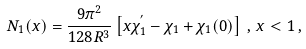<formula> <loc_0><loc_0><loc_500><loc_500>N _ { 1 } ( x ) = \frac { 9 \pi ^ { 2 } } { 1 2 8 R ^ { 3 } } \left [ x \chi _ { 1 } ^ { ^ { \prime } } - \chi _ { 1 } + \chi _ { 1 } ( 0 ) \right ] \, , \, x < 1 \, ,</formula> 